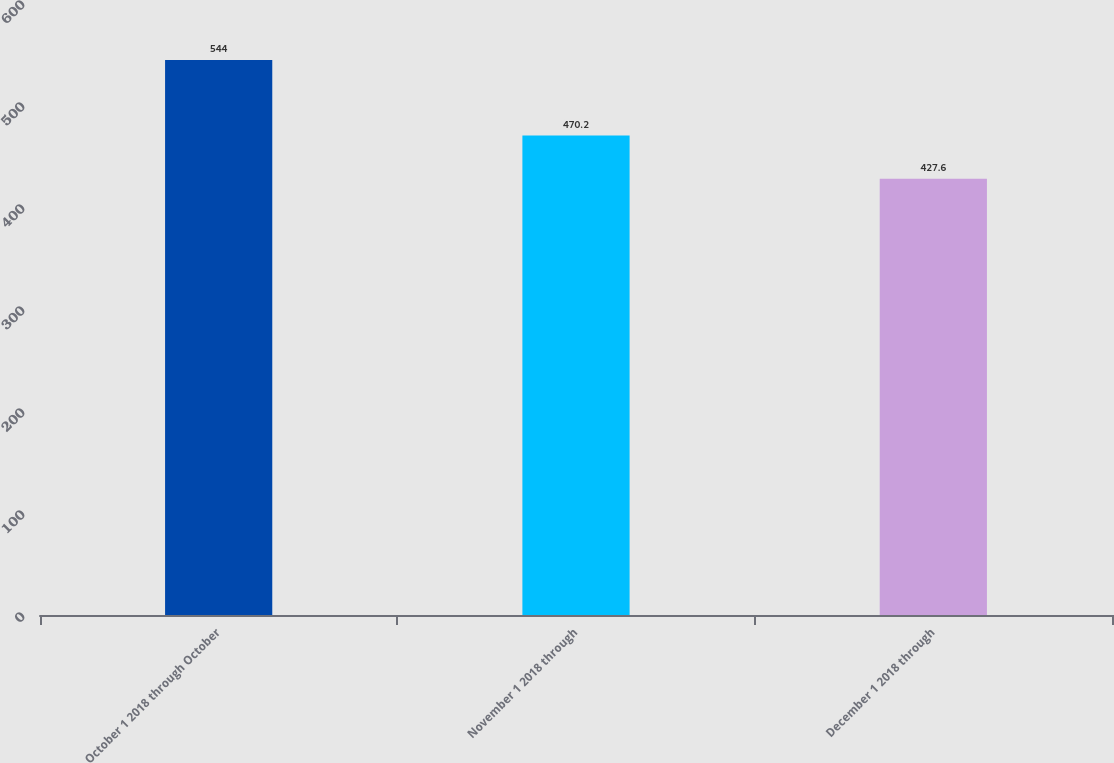Convert chart. <chart><loc_0><loc_0><loc_500><loc_500><bar_chart><fcel>October 1 2018 through October<fcel>November 1 2018 through<fcel>December 1 2018 through<nl><fcel>544<fcel>470.2<fcel>427.6<nl></chart> 